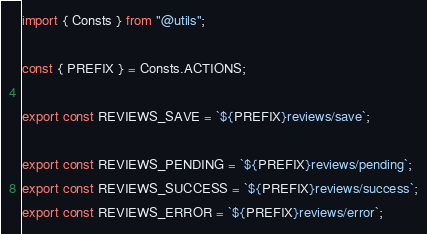<code> <loc_0><loc_0><loc_500><loc_500><_JavaScript_>import { Consts } from "@utils";

const { PREFIX } = Consts.ACTIONS;

export const REVIEWS_SAVE = `${PREFIX}reviews/save`;

export const REVIEWS_PENDING = `${PREFIX}reviews/pending`;
export const REVIEWS_SUCCESS = `${PREFIX}reviews/success`;
export const REVIEWS_ERROR = `${PREFIX}reviews/error`;
</code> 